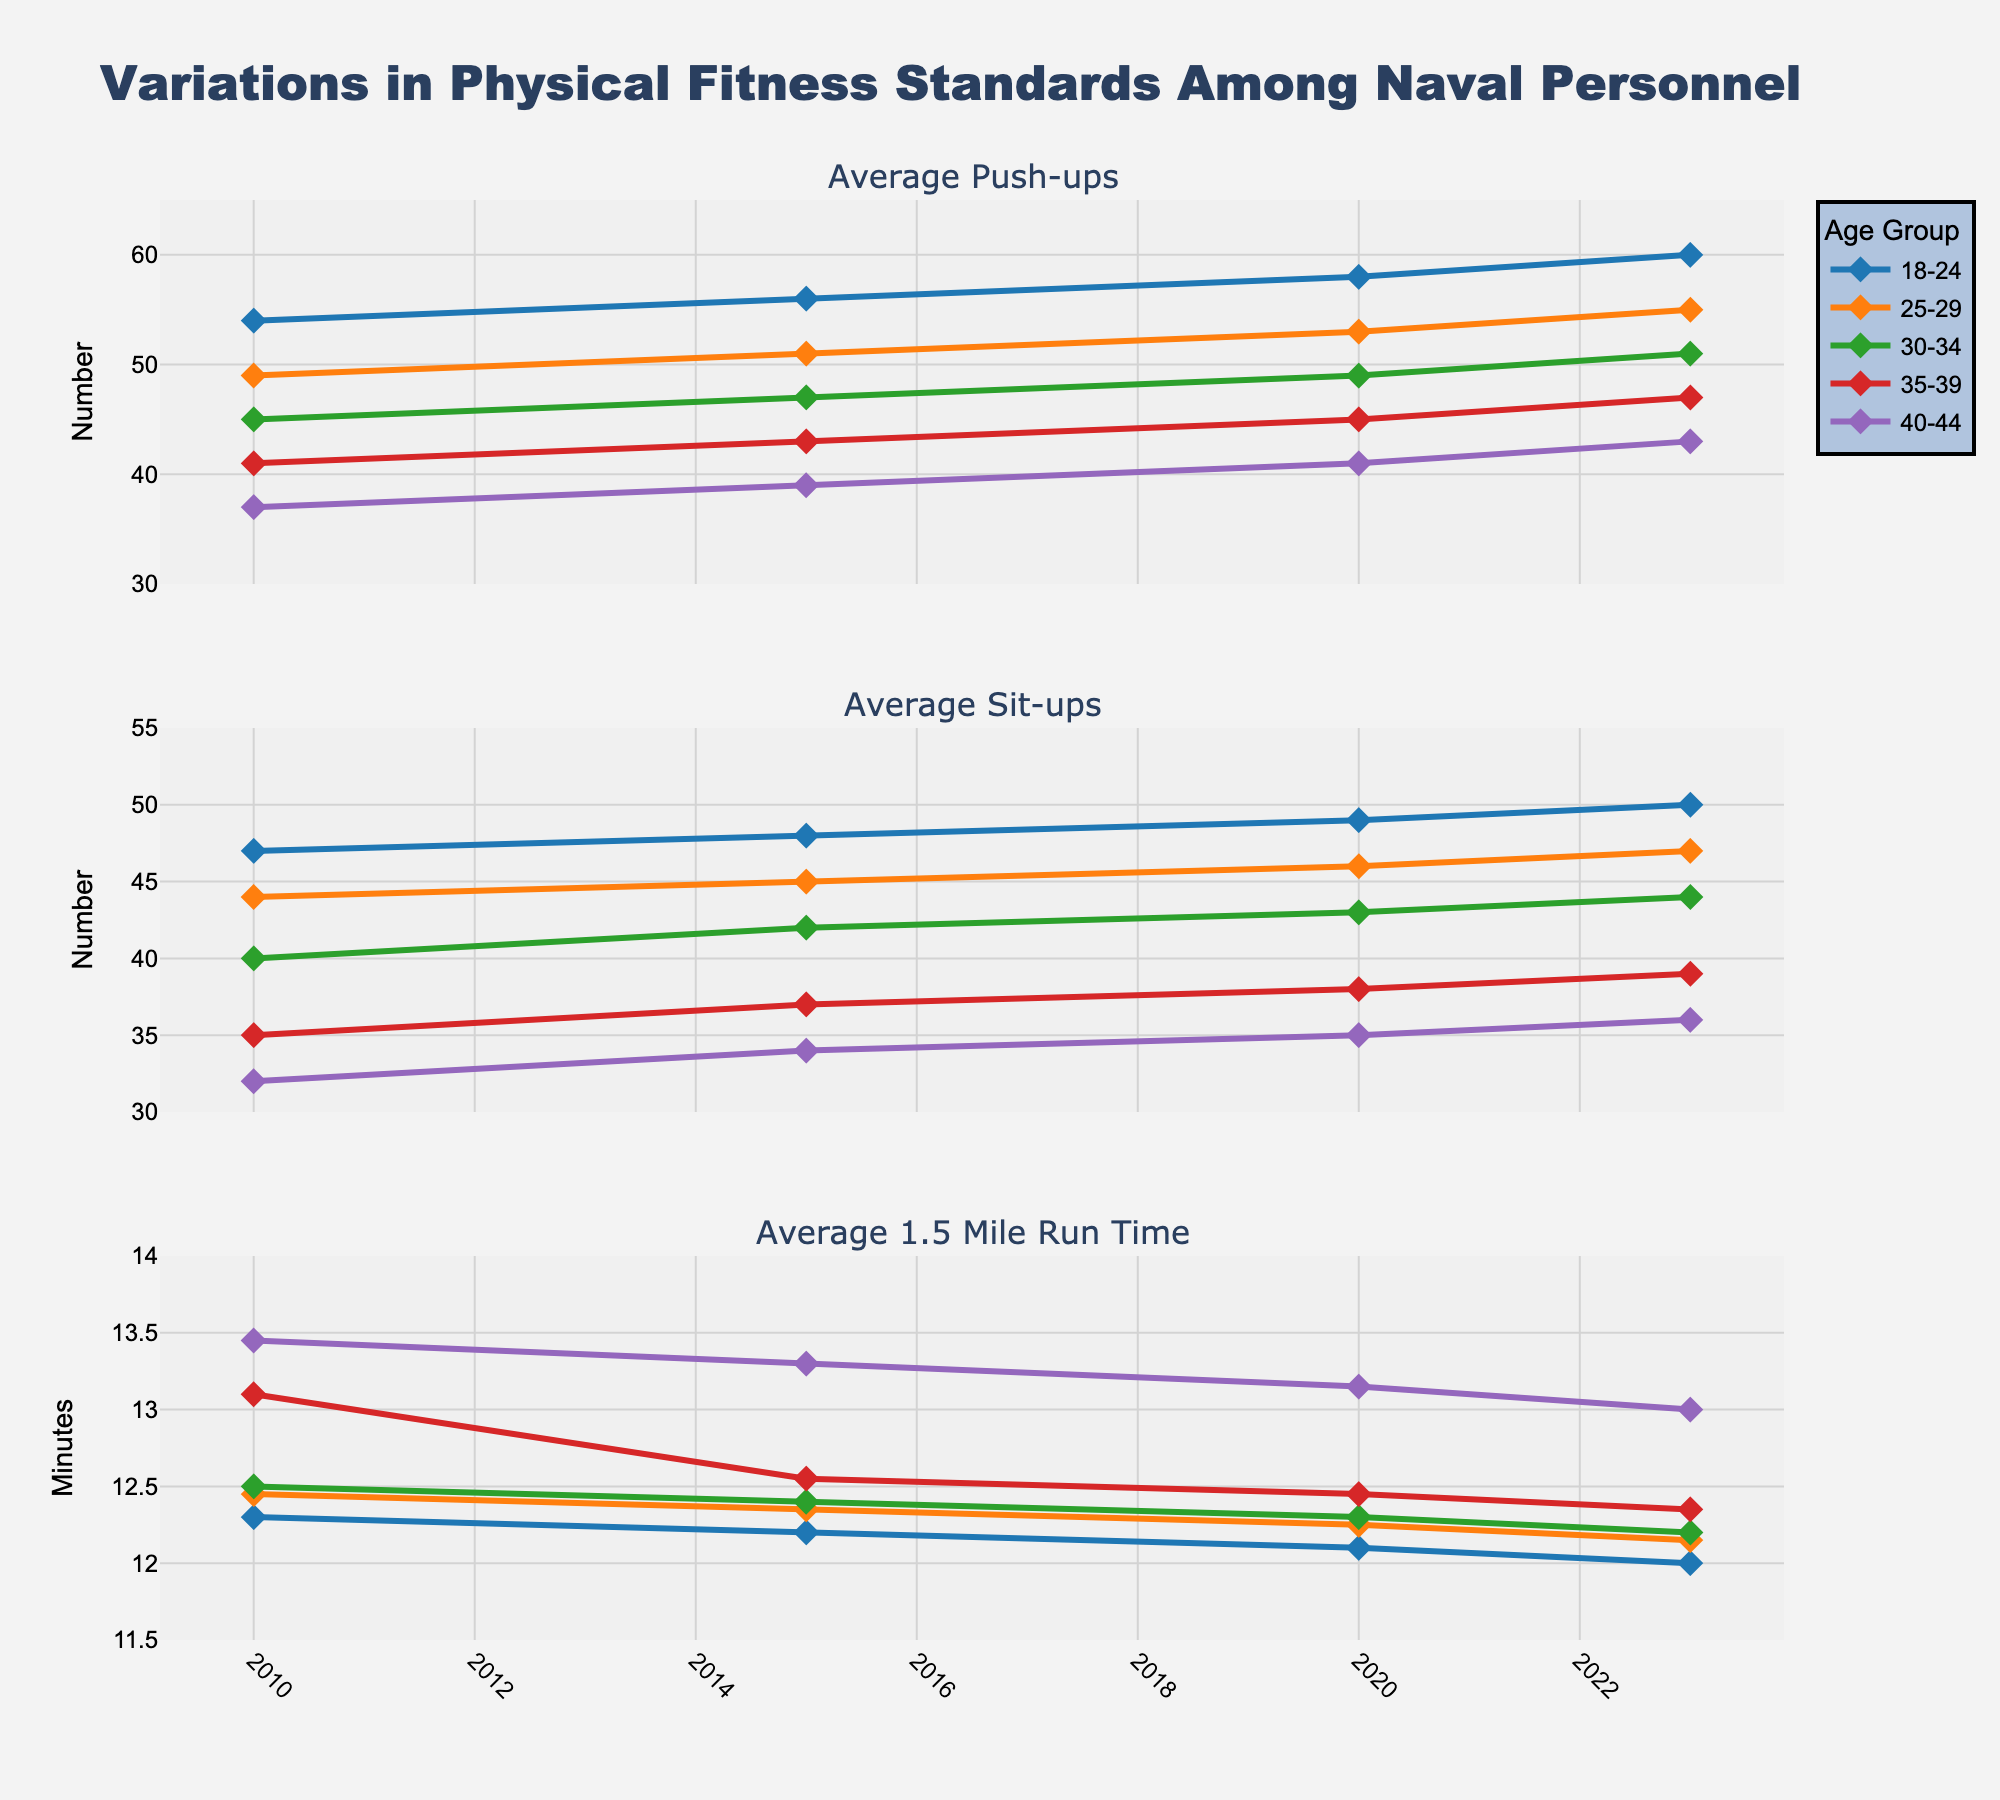What is the title of the figure? The title of the figure is located at the top and prominently displayed. It summarizes the main topic of the visualization.
Answer: Variations in Physical Fitness Standards Among Naval Personnel How many different age groups are represented in the figure? By examining the legend or the different colored lines in the subplots, we can see the number of age groups.
Answer: 5 Which age group showed the highest average number of push-ups in 2023? Look at the data points for the year 2023 in the first subplot. Identify the highest value and check which age group it belongs to.
Answer: 18-24 Compare the average number of sit-ups performed by the 30-34 age group between 2010 and 2023. What is the difference? Identify the number of sit-ups performed by the 30-34 age group in 2010 and 2023 from the second subplot and calculate the difference.
Answer: 4 Did any age group show an increase in their average 1.5-mile run time from 2010 to 2023? Look at the third subplot and compare the run times for each age group between 2010 and 2023. Determine if any age group shows an increase.
Answer: No Across all age groups, which year shows the lowest average run time for the 1.5-mile run in the third subplot? Look at the third subplot and compare the run times across all years. Identify the year with the lowest average run time.
Answer: 2023 For the 25-29 age group, how did the average number of push-ups change over time from 2010 to 2023? Track the data points for the 25-29 age group in the first subplot from 2010 to 2023 and note the trend.
Answer: Increased Which age group had the smallest variation in average sit-ups over the years displayed? Compare the range of data points (highest - lowest) for each age group in the second subplot. The group with the smallest range has the smallest variation.
Answer: 18-24 Is there any age group that consistently performed the same number of push-ups or sit-ups across all years? By looking at the first and second subplots, observe if any age group has horizontal lines (same values) across all years.
Answer: No Which age group exhibited the most improvement in their average 1.5-mile run time from 2010 to 2023? Calculate the difference in run times from 2010 to 2023 for each age group in the third subplot and identify the group with the largest improvement (decrease in time).
Answer: 18-24 